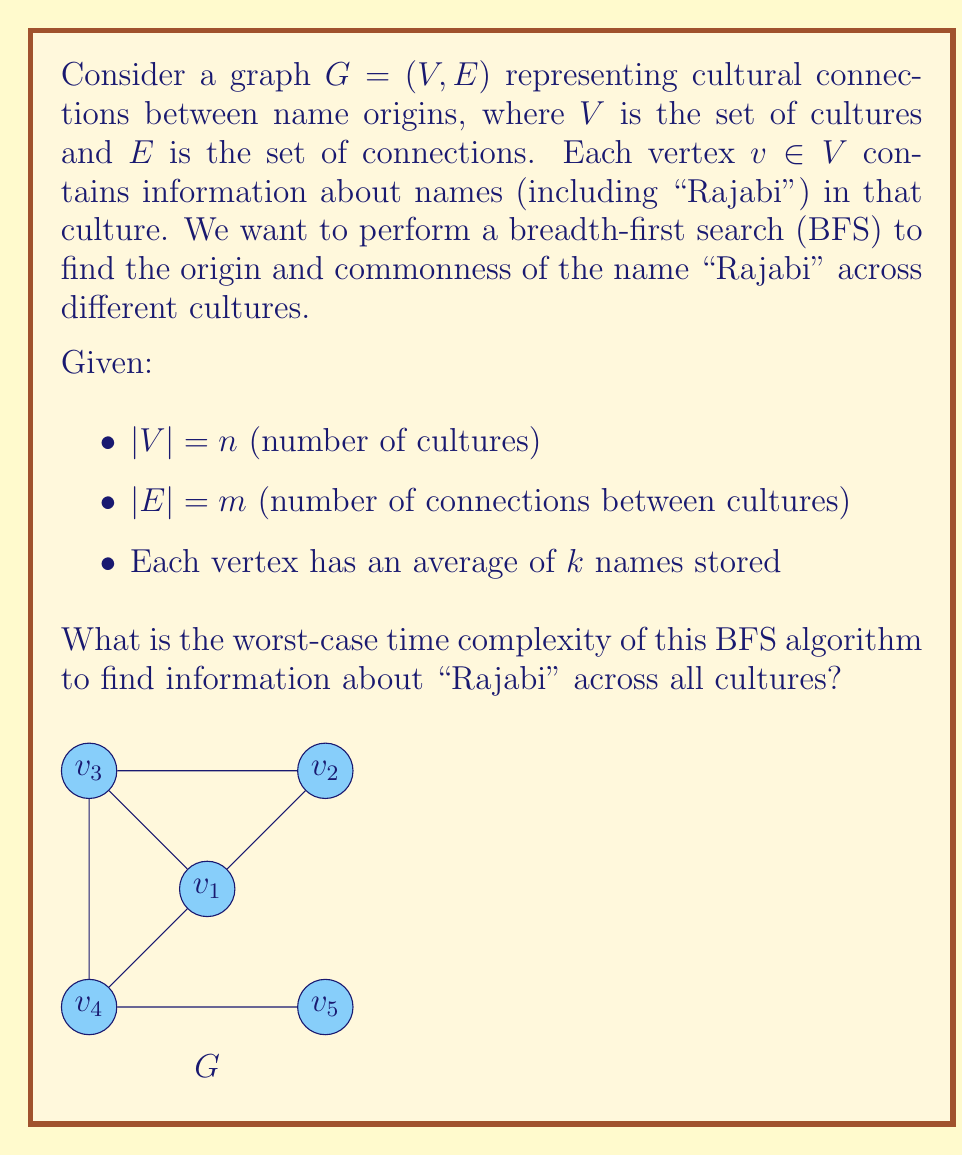Help me with this question. Let's analyze the BFS algorithm step by step:

1) Initialization:
   - Creating a queue and visited set: $O(1)$

2) BFS traversal:
   - In the worst case, we visit all vertices: $O(n)$
   - For each vertex, we explore all its adjacent edges: $O(m)$ in total
   - Total for BFS traversal: $O(n + m)$

3) Name search at each vertex:
   - At each vertex, we search for "Rajabi" among $k$ names on average
   - Linear search in each vertex: $O(k)$
   - This is done for all $n$ vertices: $O(nk)$

4) Combining steps:
   - Total complexity: $O(1 + (n + m) + nk)$
   - Simplifying: $O(n + m + nk)$

5) Worst-case scenario:
   - In a connected graph, $m \geq n - 1$
   - Therefore, $O(n + m + nk)$ can be simplified to $O(m + nk)$

The worst-case time complexity is thus $O(m + nk)$, where $m$ is the number of connections between cultures, $n$ is the number of cultures, and $k$ is the average number of names stored in each culture.
Answer: $O(m + nk)$ 